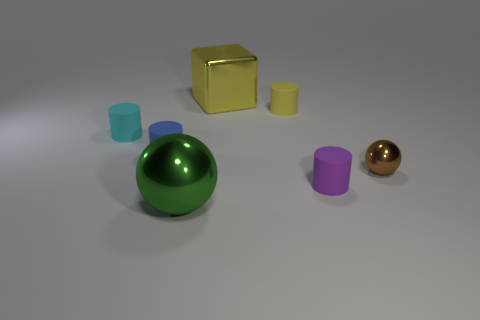Subtract all purple matte cylinders. How many cylinders are left? 3 Subtract 1 blocks. How many blocks are left? 0 Add 1 big gray metal blocks. How many objects exist? 8 Subtract all blue cylinders. How many cylinders are left? 3 Add 6 big metallic spheres. How many big metallic spheres exist? 7 Subtract 0 blue spheres. How many objects are left? 7 Subtract all cylinders. How many objects are left? 3 Subtract all purple cylinders. Subtract all yellow balls. How many cylinders are left? 3 Subtract all brown cylinders. How many cyan balls are left? 0 Subtract all yellow rubber cylinders. Subtract all yellow metallic objects. How many objects are left? 5 